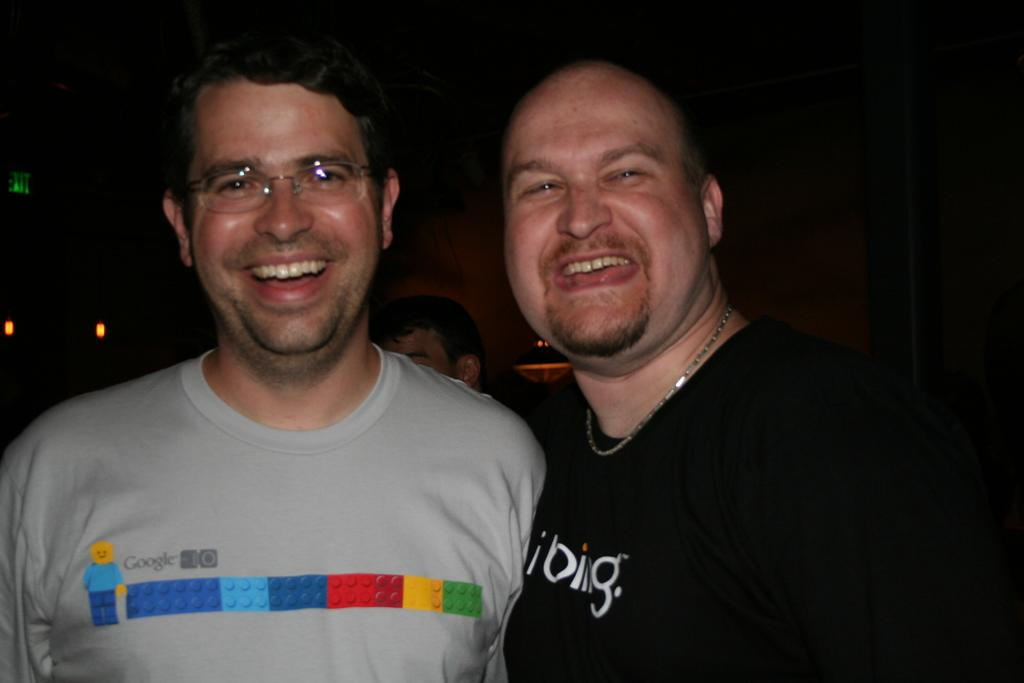Where was the image taken? The image was taken indoors. What can be observed about the lighting in the image? The background of the image is dark. Can you describe the main subject of the image? There is a person in the image. How many men are standing in the middle of the image? Two men are standing in the middle of the image. What is the facial expression of the two men? The two men have smiling faces. What type of water feature can be seen in the background of the image? There is no water feature present in the image; it was taken indoors with a dark background. 